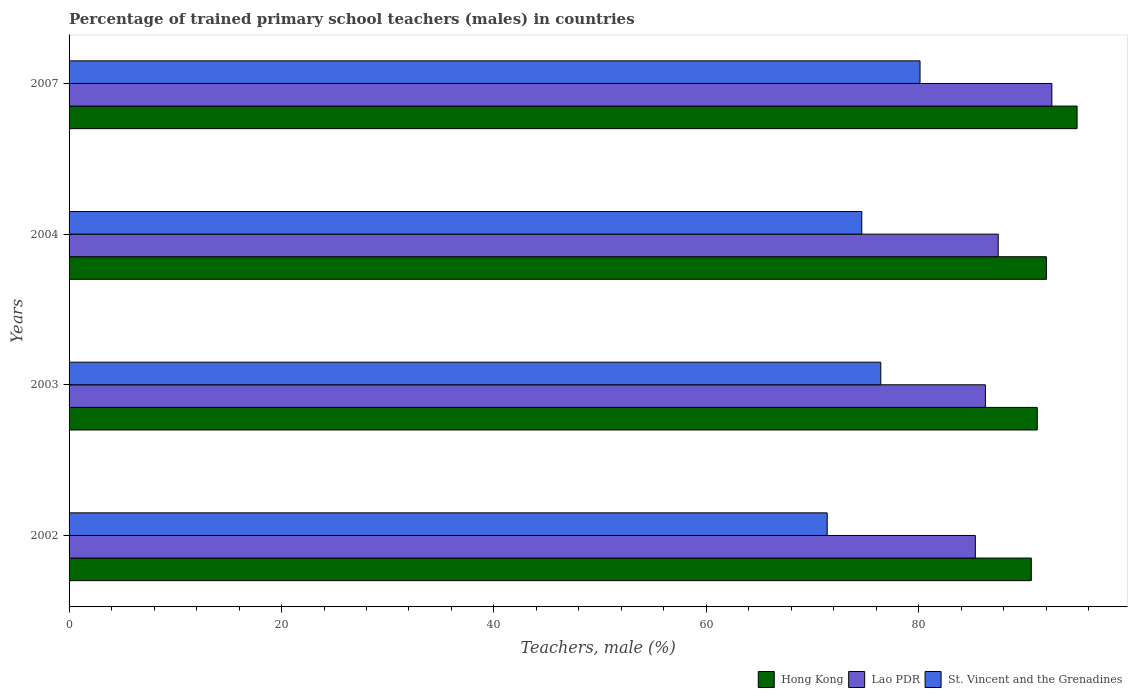How many groups of bars are there?
Your answer should be compact. 4. Are the number of bars per tick equal to the number of legend labels?
Offer a very short reply. Yes. Are the number of bars on each tick of the Y-axis equal?
Keep it short and to the point. Yes. How many bars are there on the 4th tick from the top?
Offer a terse response. 3. What is the label of the 2nd group of bars from the top?
Provide a succinct answer. 2004. In how many cases, is the number of bars for a given year not equal to the number of legend labels?
Offer a terse response. 0. What is the percentage of trained primary school teachers (males) in St. Vincent and the Grenadines in 2003?
Ensure brevity in your answer.  76.42. Across all years, what is the maximum percentage of trained primary school teachers (males) in St. Vincent and the Grenadines?
Your response must be concise. 80.11. Across all years, what is the minimum percentage of trained primary school teachers (males) in St. Vincent and the Grenadines?
Provide a succinct answer. 71.37. In which year was the percentage of trained primary school teachers (males) in Hong Kong minimum?
Provide a short and direct response. 2002. What is the total percentage of trained primary school teachers (males) in St. Vincent and the Grenadines in the graph?
Provide a short and direct response. 302.53. What is the difference between the percentage of trained primary school teachers (males) in Hong Kong in 2004 and that in 2007?
Make the answer very short. -2.89. What is the difference between the percentage of trained primary school teachers (males) in Lao PDR in 2003 and the percentage of trained primary school teachers (males) in St. Vincent and the Grenadines in 2002?
Keep it short and to the point. 14.89. What is the average percentage of trained primary school teachers (males) in Hong Kong per year?
Ensure brevity in your answer.  92.16. In the year 2004, what is the difference between the percentage of trained primary school teachers (males) in Lao PDR and percentage of trained primary school teachers (males) in St. Vincent and the Grenadines?
Give a very brief answer. 12.85. What is the ratio of the percentage of trained primary school teachers (males) in Hong Kong in 2002 to that in 2004?
Make the answer very short. 0.98. Is the percentage of trained primary school teachers (males) in Lao PDR in 2004 less than that in 2007?
Provide a short and direct response. Yes. Is the difference between the percentage of trained primary school teachers (males) in Lao PDR in 2002 and 2007 greater than the difference between the percentage of trained primary school teachers (males) in St. Vincent and the Grenadines in 2002 and 2007?
Offer a terse response. Yes. What is the difference between the highest and the second highest percentage of trained primary school teachers (males) in Hong Kong?
Your response must be concise. 2.89. What is the difference between the highest and the lowest percentage of trained primary school teachers (males) in Lao PDR?
Make the answer very short. 7.2. What does the 2nd bar from the top in 2003 represents?
Offer a terse response. Lao PDR. What does the 3rd bar from the bottom in 2003 represents?
Provide a short and direct response. St. Vincent and the Grenadines. Is it the case that in every year, the sum of the percentage of trained primary school teachers (males) in Lao PDR and percentage of trained primary school teachers (males) in Hong Kong is greater than the percentage of trained primary school teachers (males) in St. Vincent and the Grenadines?
Make the answer very short. Yes. How many bars are there?
Offer a terse response. 12. How many years are there in the graph?
Offer a terse response. 4. Are the values on the major ticks of X-axis written in scientific E-notation?
Your answer should be very brief. No. Does the graph contain any zero values?
Provide a short and direct response. No. Where does the legend appear in the graph?
Offer a terse response. Bottom right. How many legend labels are there?
Make the answer very short. 3. What is the title of the graph?
Ensure brevity in your answer.  Percentage of trained primary school teachers (males) in countries. Does "East Asia (all income levels)" appear as one of the legend labels in the graph?
Provide a short and direct response. No. What is the label or title of the X-axis?
Your response must be concise. Teachers, male (%). What is the label or title of the Y-axis?
Offer a terse response. Years. What is the Teachers, male (%) of Hong Kong in 2002?
Your answer should be compact. 90.59. What is the Teachers, male (%) of Lao PDR in 2002?
Offer a terse response. 85.32. What is the Teachers, male (%) of St. Vincent and the Grenadines in 2002?
Ensure brevity in your answer.  71.37. What is the Teachers, male (%) of Hong Kong in 2003?
Your answer should be very brief. 91.15. What is the Teachers, male (%) of Lao PDR in 2003?
Make the answer very short. 86.26. What is the Teachers, male (%) in St. Vincent and the Grenadines in 2003?
Offer a very short reply. 76.42. What is the Teachers, male (%) of Hong Kong in 2004?
Your answer should be very brief. 92.01. What is the Teachers, male (%) of Lao PDR in 2004?
Offer a terse response. 87.47. What is the Teachers, male (%) in St. Vincent and the Grenadines in 2004?
Your response must be concise. 74.63. What is the Teachers, male (%) of Hong Kong in 2007?
Make the answer very short. 94.9. What is the Teachers, male (%) in Lao PDR in 2007?
Your response must be concise. 92.52. What is the Teachers, male (%) of St. Vincent and the Grenadines in 2007?
Your answer should be very brief. 80.11. Across all years, what is the maximum Teachers, male (%) in Hong Kong?
Offer a very short reply. 94.9. Across all years, what is the maximum Teachers, male (%) of Lao PDR?
Your answer should be compact. 92.52. Across all years, what is the maximum Teachers, male (%) in St. Vincent and the Grenadines?
Make the answer very short. 80.11. Across all years, what is the minimum Teachers, male (%) of Hong Kong?
Offer a very short reply. 90.59. Across all years, what is the minimum Teachers, male (%) in Lao PDR?
Provide a short and direct response. 85.32. Across all years, what is the minimum Teachers, male (%) of St. Vincent and the Grenadines?
Your answer should be very brief. 71.37. What is the total Teachers, male (%) in Hong Kong in the graph?
Your response must be concise. 368.64. What is the total Teachers, male (%) in Lao PDR in the graph?
Your answer should be compact. 351.57. What is the total Teachers, male (%) of St. Vincent and the Grenadines in the graph?
Provide a short and direct response. 302.53. What is the difference between the Teachers, male (%) in Hong Kong in 2002 and that in 2003?
Ensure brevity in your answer.  -0.56. What is the difference between the Teachers, male (%) in Lao PDR in 2002 and that in 2003?
Make the answer very short. -0.95. What is the difference between the Teachers, male (%) in St. Vincent and the Grenadines in 2002 and that in 2003?
Offer a very short reply. -5.05. What is the difference between the Teachers, male (%) of Hong Kong in 2002 and that in 2004?
Keep it short and to the point. -1.42. What is the difference between the Teachers, male (%) in Lao PDR in 2002 and that in 2004?
Ensure brevity in your answer.  -2.15. What is the difference between the Teachers, male (%) in St. Vincent and the Grenadines in 2002 and that in 2004?
Provide a short and direct response. -3.26. What is the difference between the Teachers, male (%) of Hong Kong in 2002 and that in 2007?
Provide a succinct answer. -4.31. What is the difference between the Teachers, male (%) of Lao PDR in 2002 and that in 2007?
Your answer should be compact. -7.2. What is the difference between the Teachers, male (%) of St. Vincent and the Grenadines in 2002 and that in 2007?
Provide a succinct answer. -8.74. What is the difference between the Teachers, male (%) of Hong Kong in 2003 and that in 2004?
Ensure brevity in your answer.  -0.86. What is the difference between the Teachers, male (%) of Lao PDR in 2003 and that in 2004?
Your response must be concise. -1.21. What is the difference between the Teachers, male (%) in St. Vincent and the Grenadines in 2003 and that in 2004?
Offer a terse response. 1.79. What is the difference between the Teachers, male (%) in Hong Kong in 2003 and that in 2007?
Your answer should be compact. -3.75. What is the difference between the Teachers, male (%) in Lao PDR in 2003 and that in 2007?
Provide a succinct answer. -6.26. What is the difference between the Teachers, male (%) of St. Vincent and the Grenadines in 2003 and that in 2007?
Make the answer very short. -3.69. What is the difference between the Teachers, male (%) in Hong Kong in 2004 and that in 2007?
Give a very brief answer. -2.89. What is the difference between the Teachers, male (%) of Lao PDR in 2004 and that in 2007?
Your response must be concise. -5.05. What is the difference between the Teachers, male (%) of St. Vincent and the Grenadines in 2004 and that in 2007?
Your answer should be compact. -5.48. What is the difference between the Teachers, male (%) in Hong Kong in 2002 and the Teachers, male (%) in Lao PDR in 2003?
Make the answer very short. 4.32. What is the difference between the Teachers, male (%) of Hong Kong in 2002 and the Teachers, male (%) of St. Vincent and the Grenadines in 2003?
Give a very brief answer. 14.17. What is the difference between the Teachers, male (%) in Lao PDR in 2002 and the Teachers, male (%) in St. Vincent and the Grenadines in 2003?
Offer a very short reply. 8.9. What is the difference between the Teachers, male (%) in Hong Kong in 2002 and the Teachers, male (%) in Lao PDR in 2004?
Provide a short and direct response. 3.11. What is the difference between the Teachers, male (%) of Hong Kong in 2002 and the Teachers, male (%) of St. Vincent and the Grenadines in 2004?
Offer a terse response. 15.96. What is the difference between the Teachers, male (%) of Lao PDR in 2002 and the Teachers, male (%) of St. Vincent and the Grenadines in 2004?
Your answer should be very brief. 10.69. What is the difference between the Teachers, male (%) of Hong Kong in 2002 and the Teachers, male (%) of Lao PDR in 2007?
Offer a very short reply. -1.94. What is the difference between the Teachers, male (%) of Hong Kong in 2002 and the Teachers, male (%) of St. Vincent and the Grenadines in 2007?
Provide a succinct answer. 10.47. What is the difference between the Teachers, male (%) in Lao PDR in 2002 and the Teachers, male (%) in St. Vincent and the Grenadines in 2007?
Your answer should be very brief. 5.21. What is the difference between the Teachers, male (%) in Hong Kong in 2003 and the Teachers, male (%) in Lao PDR in 2004?
Provide a short and direct response. 3.67. What is the difference between the Teachers, male (%) of Hong Kong in 2003 and the Teachers, male (%) of St. Vincent and the Grenadines in 2004?
Keep it short and to the point. 16.52. What is the difference between the Teachers, male (%) of Lao PDR in 2003 and the Teachers, male (%) of St. Vincent and the Grenadines in 2004?
Ensure brevity in your answer.  11.64. What is the difference between the Teachers, male (%) of Hong Kong in 2003 and the Teachers, male (%) of Lao PDR in 2007?
Provide a short and direct response. -1.37. What is the difference between the Teachers, male (%) in Hong Kong in 2003 and the Teachers, male (%) in St. Vincent and the Grenadines in 2007?
Provide a succinct answer. 11.04. What is the difference between the Teachers, male (%) in Lao PDR in 2003 and the Teachers, male (%) in St. Vincent and the Grenadines in 2007?
Provide a short and direct response. 6.15. What is the difference between the Teachers, male (%) in Hong Kong in 2004 and the Teachers, male (%) in Lao PDR in 2007?
Your answer should be compact. -0.51. What is the difference between the Teachers, male (%) of Hong Kong in 2004 and the Teachers, male (%) of St. Vincent and the Grenadines in 2007?
Your answer should be very brief. 11.9. What is the difference between the Teachers, male (%) of Lao PDR in 2004 and the Teachers, male (%) of St. Vincent and the Grenadines in 2007?
Make the answer very short. 7.36. What is the average Teachers, male (%) in Hong Kong per year?
Your response must be concise. 92.16. What is the average Teachers, male (%) of Lao PDR per year?
Your response must be concise. 87.89. What is the average Teachers, male (%) in St. Vincent and the Grenadines per year?
Offer a very short reply. 75.63. In the year 2002, what is the difference between the Teachers, male (%) of Hong Kong and Teachers, male (%) of Lao PDR?
Give a very brief answer. 5.27. In the year 2002, what is the difference between the Teachers, male (%) of Hong Kong and Teachers, male (%) of St. Vincent and the Grenadines?
Keep it short and to the point. 19.21. In the year 2002, what is the difference between the Teachers, male (%) in Lao PDR and Teachers, male (%) in St. Vincent and the Grenadines?
Your response must be concise. 13.95. In the year 2003, what is the difference between the Teachers, male (%) in Hong Kong and Teachers, male (%) in Lao PDR?
Provide a succinct answer. 4.88. In the year 2003, what is the difference between the Teachers, male (%) of Hong Kong and Teachers, male (%) of St. Vincent and the Grenadines?
Your answer should be compact. 14.73. In the year 2003, what is the difference between the Teachers, male (%) of Lao PDR and Teachers, male (%) of St. Vincent and the Grenadines?
Provide a succinct answer. 9.85. In the year 2004, what is the difference between the Teachers, male (%) of Hong Kong and Teachers, male (%) of Lao PDR?
Ensure brevity in your answer.  4.54. In the year 2004, what is the difference between the Teachers, male (%) of Hong Kong and Teachers, male (%) of St. Vincent and the Grenadines?
Keep it short and to the point. 17.38. In the year 2004, what is the difference between the Teachers, male (%) of Lao PDR and Teachers, male (%) of St. Vincent and the Grenadines?
Offer a terse response. 12.85. In the year 2007, what is the difference between the Teachers, male (%) of Hong Kong and Teachers, male (%) of Lao PDR?
Your answer should be compact. 2.38. In the year 2007, what is the difference between the Teachers, male (%) of Hong Kong and Teachers, male (%) of St. Vincent and the Grenadines?
Provide a short and direct response. 14.79. In the year 2007, what is the difference between the Teachers, male (%) of Lao PDR and Teachers, male (%) of St. Vincent and the Grenadines?
Keep it short and to the point. 12.41. What is the ratio of the Teachers, male (%) in Lao PDR in 2002 to that in 2003?
Provide a short and direct response. 0.99. What is the ratio of the Teachers, male (%) in St. Vincent and the Grenadines in 2002 to that in 2003?
Provide a succinct answer. 0.93. What is the ratio of the Teachers, male (%) of Hong Kong in 2002 to that in 2004?
Your response must be concise. 0.98. What is the ratio of the Teachers, male (%) in Lao PDR in 2002 to that in 2004?
Keep it short and to the point. 0.98. What is the ratio of the Teachers, male (%) in St. Vincent and the Grenadines in 2002 to that in 2004?
Give a very brief answer. 0.96. What is the ratio of the Teachers, male (%) in Hong Kong in 2002 to that in 2007?
Your response must be concise. 0.95. What is the ratio of the Teachers, male (%) of Lao PDR in 2002 to that in 2007?
Make the answer very short. 0.92. What is the ratio of the Teachers, male (%) of St. Vincent and the Grenadines in 2002 to that in 2007?
Offer a terse response. 0.89. What is the ratio of the Teachers, male (%) of Hong Kong in 2003 to that in 2004?
Your response must be concise. 0.99. What is the ratio of the Teachers, male (%) of Lao PDR in 2003 to that in 2004?
Your response must be concise. 0.99. What is the ratio of the Teachers, male (%) of St. Vincent and the Grenadines in 2003 to that in 2004?
Offer a terse response. 1.02. What is the ratio of the Teachers, male (%) in Hong Kong in 2003 to that in 2007?
Give a very brief answer. 0.96. What is the ratio of the Teachers, male (%) of Lao PDR in 2003 to that in 2007?
Your answer should be compact. 0.93. What is the ratio of the Teachers, male (%) of St. Vincent and the Grenadines in 2003 to that in 2007?
Keep it short and to the point. 0.95. What is the ratio of the Teachers, male (%) in Hong Kong in 2004 to that in 2007?
Offer a terse response. 0.97. What is the ratio of the Teachers, male (%) of Lao PDR in 2004 to that in 2007?
Give a very brief answer. 0.95. What is the ratio of the Teachers, male (%) of St. Vincent and the Grenadines in 2004 to that in 2007?
Ensure brevity in your answer.  0.93. What is the difference between the highest and the second highest Teachers, male (%) in Hong Kong?
Ensure brevity in your answer.  2.89. What is the difference between the highest and the second highest Teachers, male (%) in Lao PDR?
Ensure brevity in your answer.  5.05. What is the difference between the highest and the second highest Teachers, male (%) in St. Vincent and the Grenadines?
Make the answer very short. 3.69. What is the difference between the highest and the lowest Teachers, male (%) of Hong Kong?
Provide a short and direct response. 4.31. What is the difference between the highest and the lowest Teachers, male (%) of Lao PDR?
Make the answer very short. 7.2. What is the difference between the highest and the lowest Teachers, male (%) in St. Vincent and the Grenadines?
Provide a short and direct response. 8.74. 